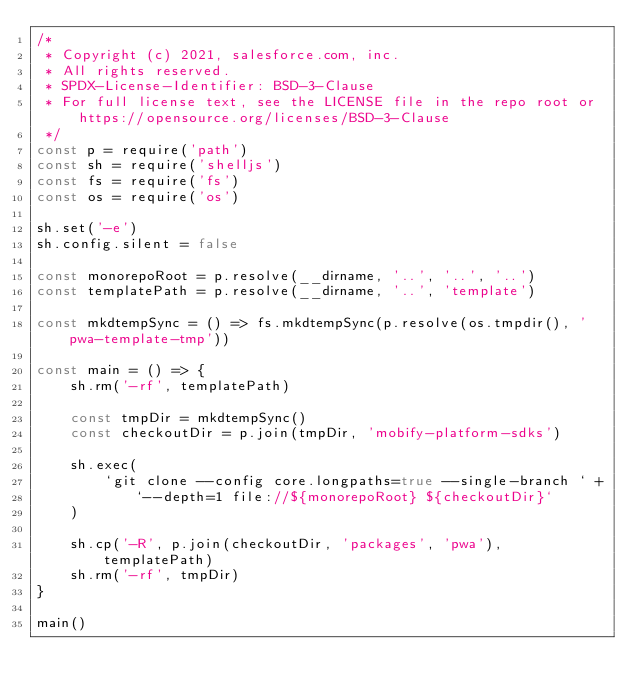<code> <loc_0><loc_0><loc_500><loc_500><_JavaScript_>/*
 * Copyright (c) 2021, salesforce.com, inc.
 * All rights reserved.
 * SPDX-License-Identifier: BSD-3-Clause
 * For full license text, see the LICENSE file in the repo root or https://opensource.org/licenses/BSD-3-Clause
 */
const p = require('path')
const sh = require('shelljs')
const fs = require('fs')
const os = require('os')

sh.set('-e')
sh.config.silent = false

const monorepoRoot = p.resolve(__dirname, '..', '..', '..')
const templatePath = p.resolve(__dirname, '..', 'template')

const mkdtempSync = () => fs.mkdtempSync(p.resolve(os.tmpdir(), 'pwa-template-tmp'))

const main = () => {
    sh.rm('-rf', templatePath)

    const tmpDir = mkdtempSync()
    const checkoutDir = p.join(tmpDir, 'mobify-platform-sdks')

    sh.exec(
        `git clone --config core.longpaths=true --single-branch ` +
            `--depth=1 file://${monorepoRoot} ${checkoutDir}`
    )

    sh.cp('-R', p.join(checkoutDir, 'packages', 'pwa'), templatePath)
    sh.rm('-rf', tmpDir)
}

main()
</code> 